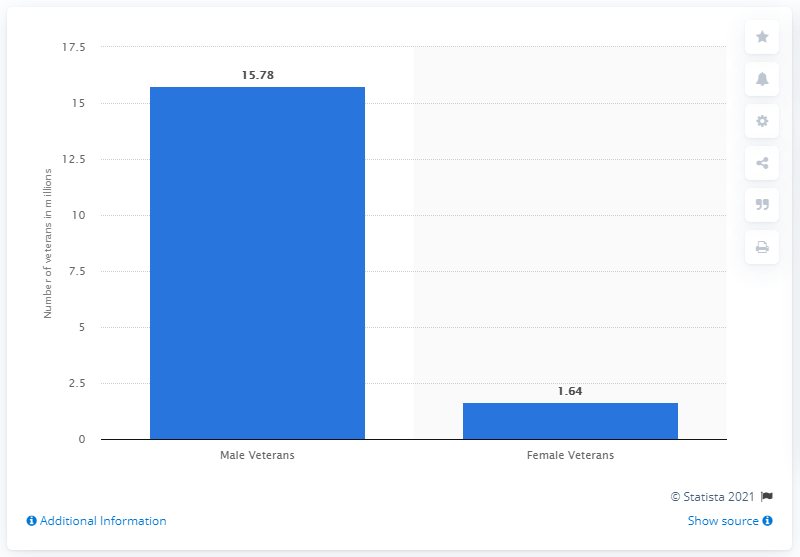Mention a couple of crucial points in this snapshot. There were 15.78 male veterans in the United States in 2019. In 2019, there were approximately 15.78 million male veterans in the United States. In 2019, the average number of male and female veterans in the United States was approximately 8.71 million, according to available data. There were 1.64 million female veterans in the United States in 2019. 